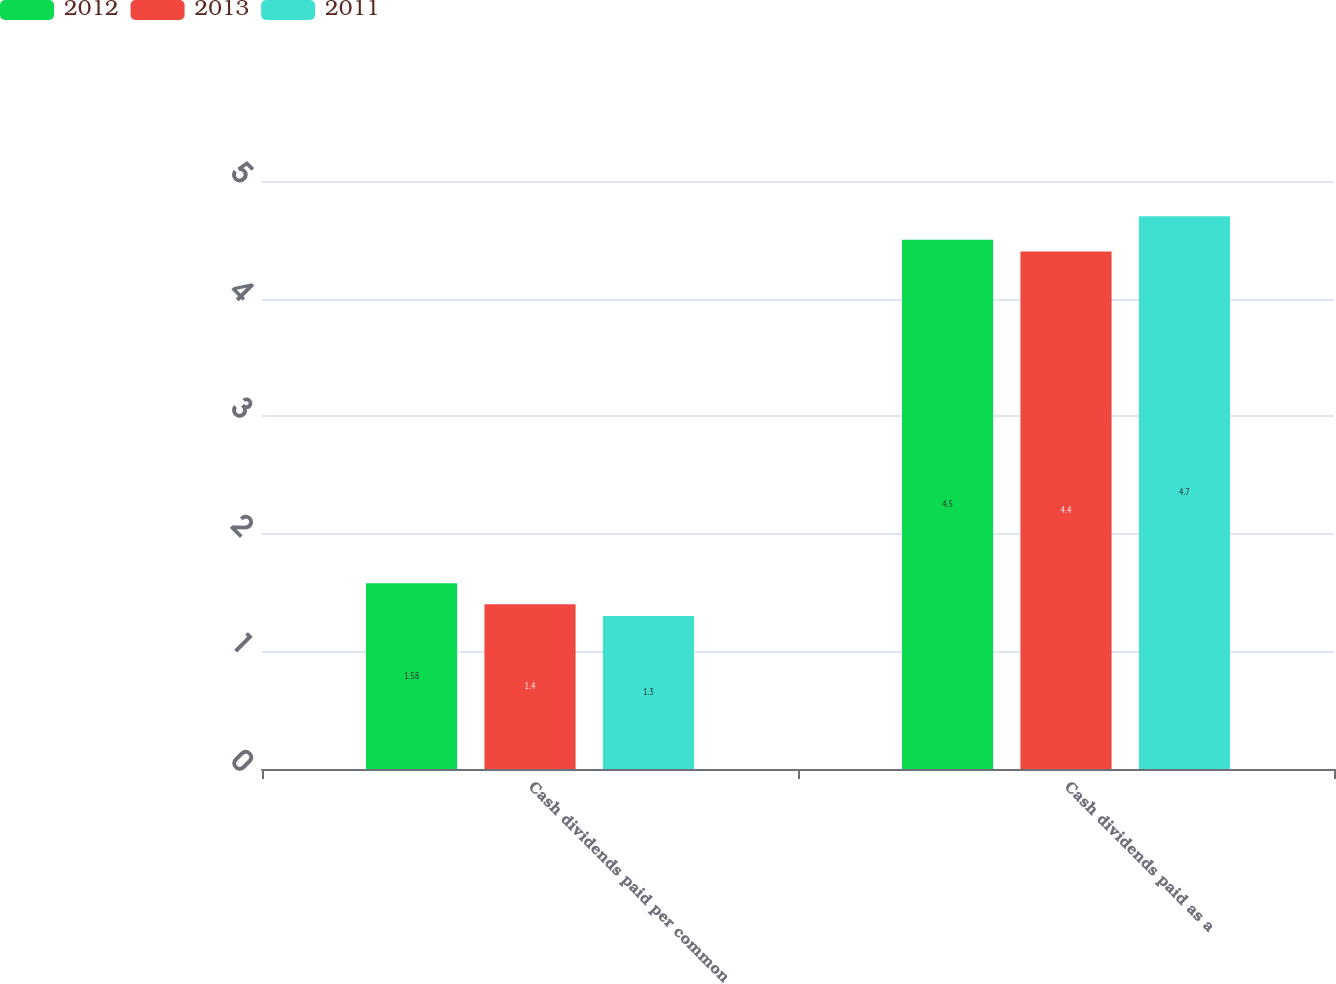Convert chart. <chart><loc_0><loc_0><loc_500><loc_500><stacked_bar_chart><ecel><fcel>Cash dividends paid per common<fcel>Cash dividends paid as a<nl><fcel>2012<fcel>1.58<fcel>4.5<nl><fcel>2013<fcel>1.4<fcel>4.4<nl><fcel>2011<fcel>1.3<fcel>4.7<nl></chart> 